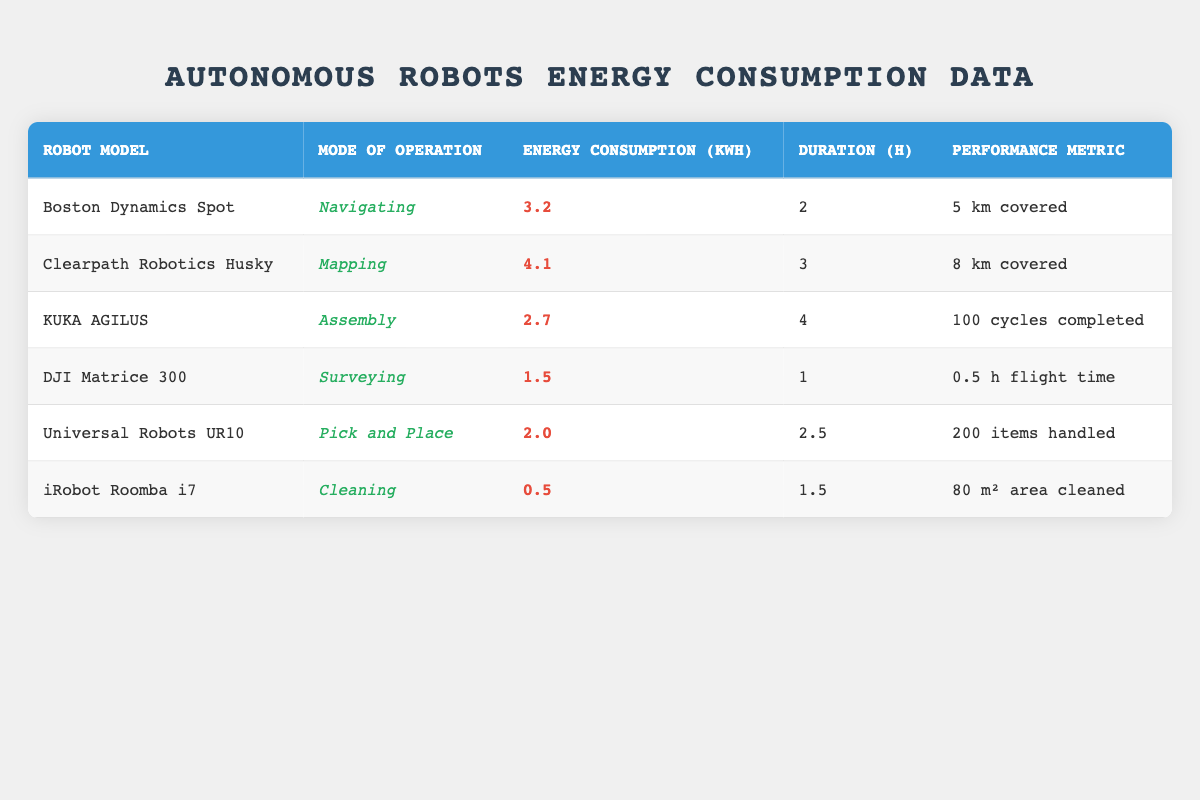what is the energy consumption of the iRobot Roomba i7? The table lists the energy consumption of the iRobot Roomba i7 as 0.5 kWh.
Answer: 0.5 kWh which robot has the highest energy consumption? By comparing the energy consumption values in the table, the Clearpath Robotics Husky has the highest energy consumption at 4.1 kWh.
Answer: 4.1 kWh how many hours did the KUKA AGILUS operate? The KUKA AGILUS, in the table, has a duration of 4 hours shown under the Duration column.
Answer: 4 hours what is the total energy consumption of all the robots combined? To find the total energy consumption, we sum the energy consumption of each robot: 3.2 + 4.1 + 2.7 + 1.5 + 2.0 + 0.5 = 14.0 kWh.
Answer: 14.0 kWh does the Boston Dynamics Spot consume more energy than the DJI Matrice 300? Comparing the energy consumption values, Boston Dynamics Spot at 3.2 kWh does consume more energy than DJI Matrice 300, which consumes 1.5 kWh.
Answer: Yes what is the average energy consumption of the robots listed in the table? To calculate the average energy consumption, first sum all the values: (3.2 + 4.1 + 2.7 + 1.5 + 2.0 + 0.5) = 14.0 kWh, then divide by the number of robots (6): 14.0 / 6 = approximately 2.33 kWh.
Answer: 2.33 kWh which robot model has the longest duration of operation? The longest duration of operation is associated with the KUKA AGILUS, which operates for 4 hours, while others operate for shorter durations.
Answer: KUKA AGILUS how many items did the Universal Robots UR10 handle during its operation? The performance metric for the Universal Robots UR10 indicates that it handled 200 items as noted in the last column of the table.
Answer: 200 items 